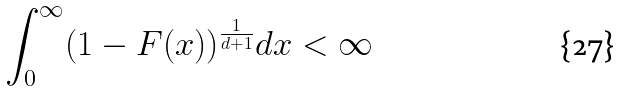Convert formula to latex. <formula><loc_0><loc_0><loc_500><loc_500>\int _ { 0 } ^ { \infty } ( 1 - F ( x ) ) ^ { \frac { 1 } { d + 1 } } d x < \infty</formula> 